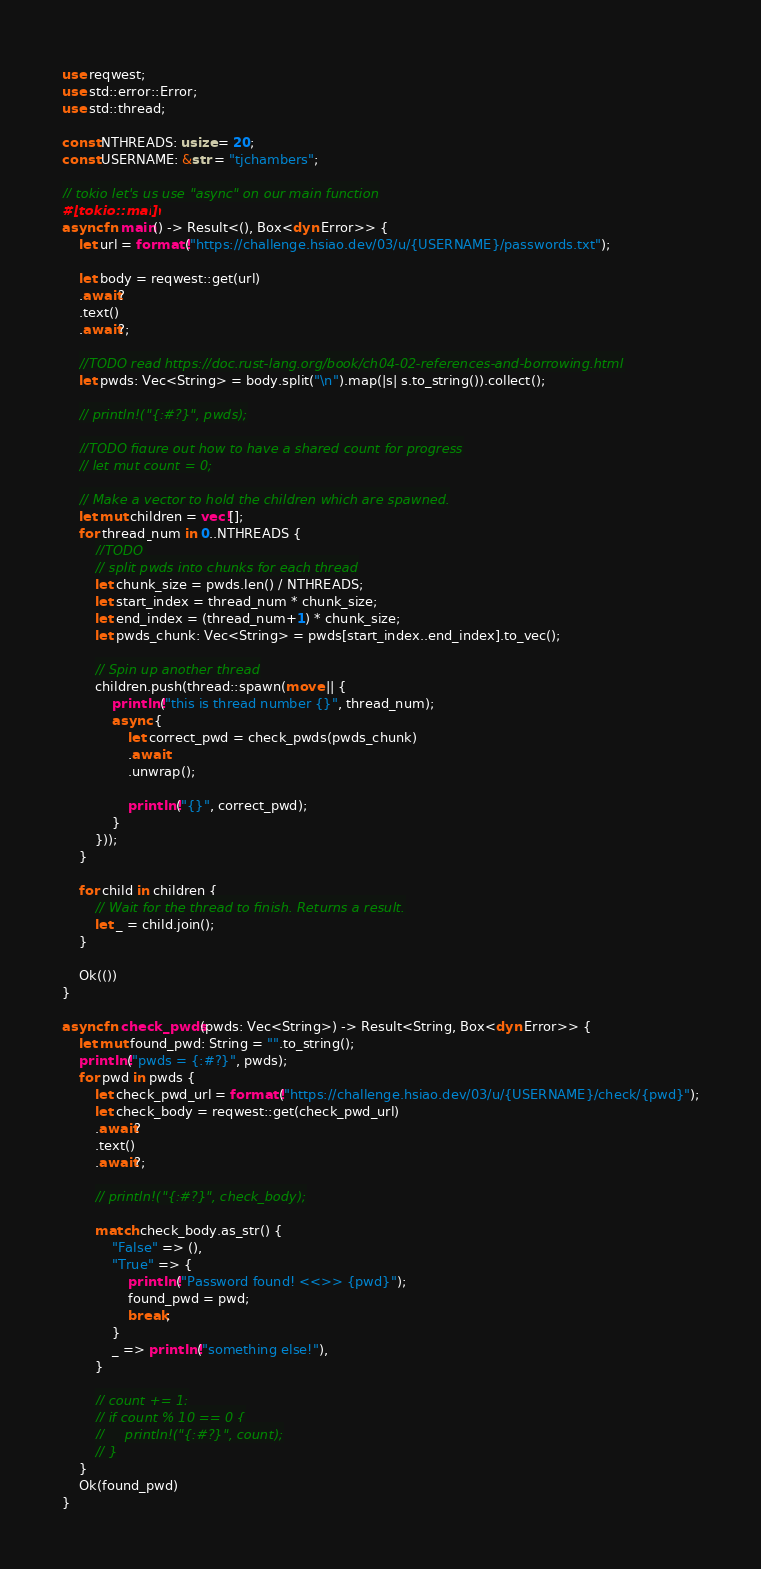<code> <loc_0><loc_0><loc_500><loc_500><_Rust_>use reqwest;
use std::error::Error;
use std::thread;

const NTHREADS: usize = 20;
const USERNAME: &str = "tjchambers";

// tokio let's us use "async" on our main function
#[tokio::main]
async fn main() -> Result<(), Box<dyn Error>> {
    let url = format!("https://challenge.hsiao.dev/03/u/{USERNAME}/passwords.txt");

    let body = reqwest::get(url)
    .await?
    .text()
    .await?;

    //TODO read https://doc.rust-lang.org/book/ch04-02-references-and-borrowing.html
    let pwds: Vec<String> = body.split("\n").map(|s| s.to_string()).collect();

    // println!("{:#?}", pwds);

    //TODO figure out how to have a shared count for progress
    // let mut count = 0;

    // Make a vector to hold the children which are spawned.
    let mut children = vec![];
    for thread_num in 0..NTHREADS {
        //TODO 
        // split pwds into chunks for each thread
        let chunk_size = pwds.len() / NTHREADS;
        let start_index = thread_num * chunk_size;
        let end_index = (thread_num+1) * chunk_size;
        let pwds_chunk: Vec<String> = pwds[start_index..end_index].to_vec();
        
        // Spin up another thread
        children.push(thread::spawn(move || {
            println!("this is thread number {}", thread_num);
            async {
                let correct_pwd = check_pwds(pwds_chunk)
                .await
                .unwrap();

                println!("{}", correct_pwd);
            }
        }));
    }

    for child in children {
        // Wait for the thread to finish. Returns a result.
        let _ = child.join();
    }

    Ok(())
}

async fn check_pwds(pwds: Vec<String>) -> Result<String, Box<dyn Error>> {
    let mut found_pwd: String = "".to_string();
    println!("pwds = {:#?}", pwds);
    for pwd in pwds {
        let check_pwd_url = format!("https://challenge.hsiao.dev/03/u/{USERNAME}/check/{pwd}");
        let check_body = reqwest::get(check_pwd_url)
        .await?
        .text()
        .await?;

        // println!("{:#?}", check_body);

        match check_body.as_str() {
            "False" => (),
            "True" => {
                println!("Password found! <<>> {pwd}");
                found_pwd = pwd;
                break;
            }
            _ => println!("something else!"),
        }

        // count += 1;
        // if count % 10 == 0 {
        //     println!("{:#?}", count);
        // }
    }
    Ok(found_pwd)
}</code> 